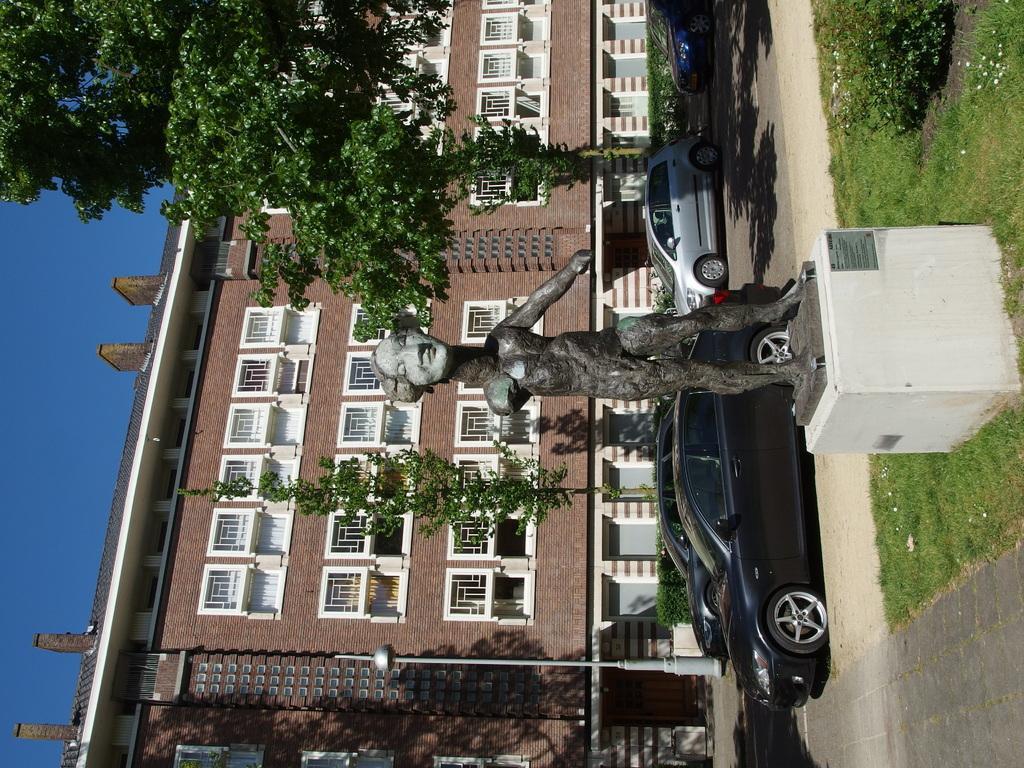Can you describe this image briefly? In the center of the image we can see a statue on a stand. We can also see some plants, grass, vehicles on the ground, a pole, trees, a building with windows and the sky which looks cloudy. 